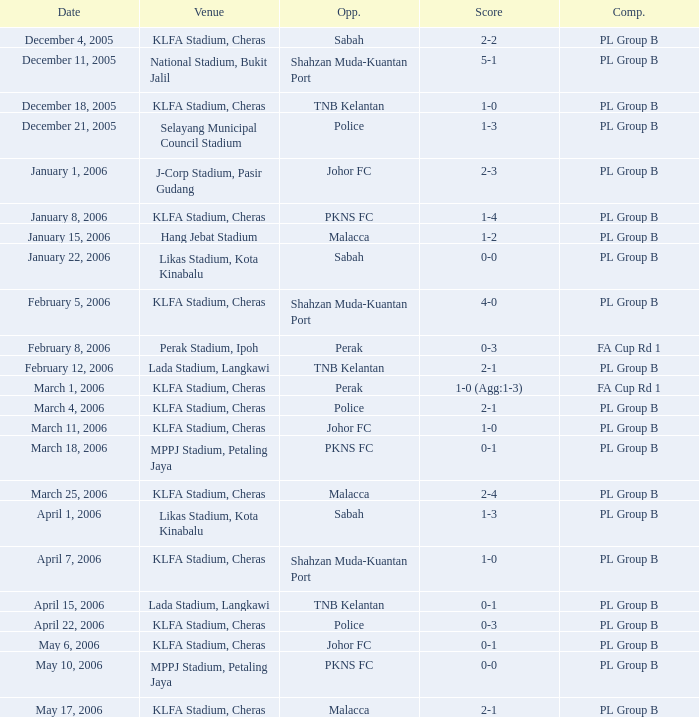Which Date has a Competition of pl group b, and Opponents of police, and a Venue of selayang municipal council stadium? December 21, 2005. 